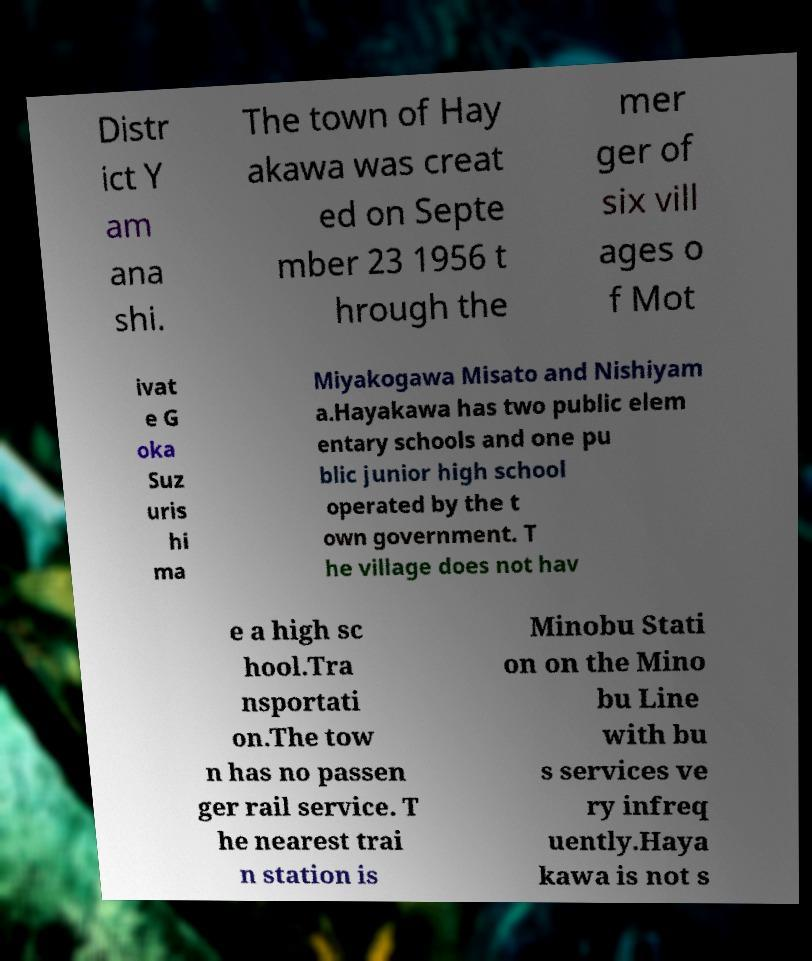For documentation purposes, I need the text within this image transcribed. Could you provide that? Distr ict Y am ana shi. The town of Hay akawa was creat ed on Septe mber 23 1956 t hrough the mer ger of six vill ages o f Mot ivat e G oka Suz uris hi ma Miyakogawa Misato and Nishiyam a.Hayakawa has two public elem entary schools and one pu blic junior high school operated by the t own government. T he village does not hav e a high sc hool.Tra nsportati on.The tow n has no passen ger rail service. T he nearest trai n station is Minobu Stati on on the Mino bu Line with bu s services ve ry infreq uently.Haya kawa is not s 